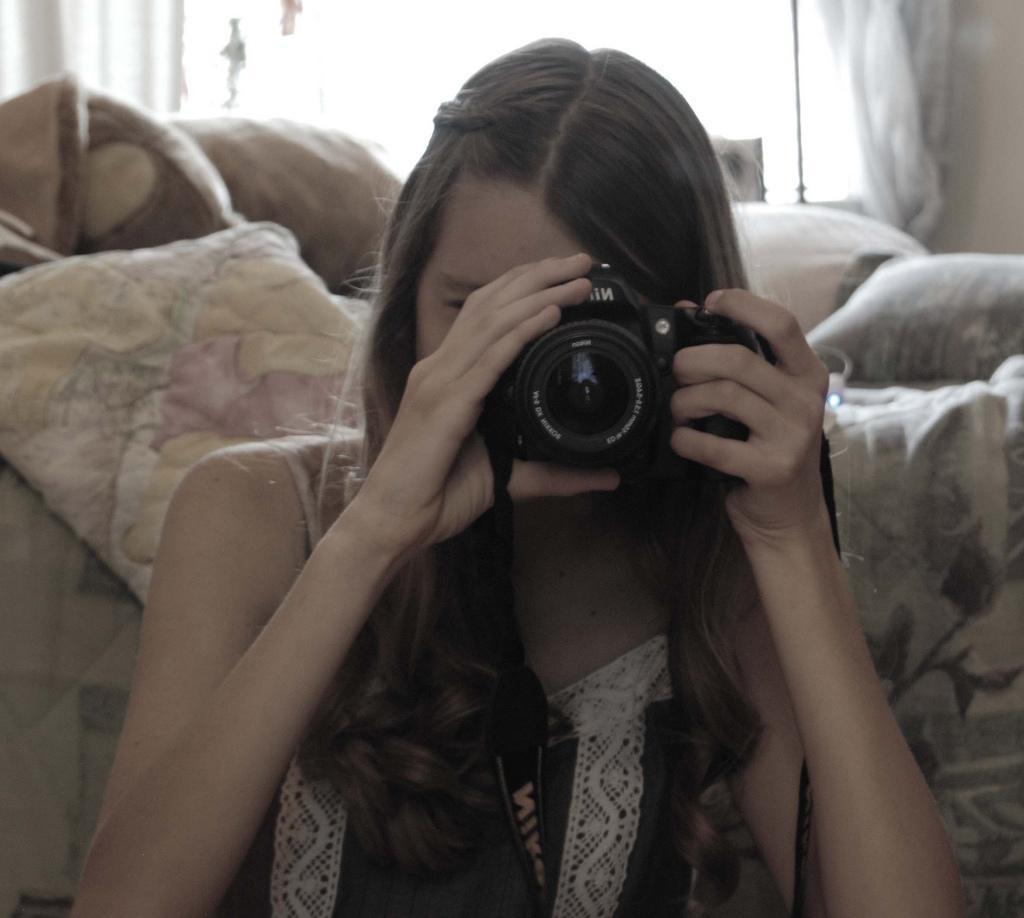How would you summarize this image in a sentence or two? In this image I see a girl who is holding the camera. In the background I see the bed. 